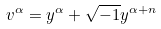Convert formula to latex. <formula><loc_0><loc_0><loc_500><loc_500>v ^ { \alpha } = y ^ { \alpha } + \sqrt { - 1 } y ^ { \alpha + n }</formula> 